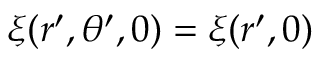<formula> <loc_0><loc_0><loc_500><loc_500>\xi ( r ^ { \prime } , \theta ^ { \prime } , 0 ) = \xi ( r ^ { \prime } , 0 )</formula> 